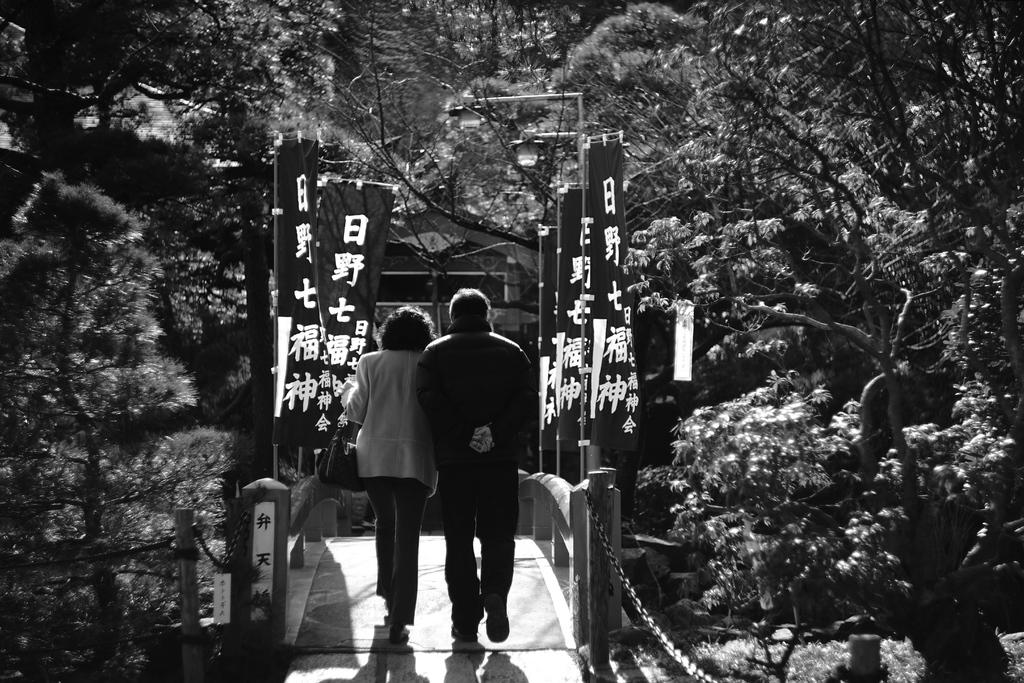What are the two persons in the image doing? The two persons in the image are walking. What object can be seen in the image that is made of metal? There is an iron chain in the image. What type of symbolic objects are present in the image? There are flags in the image. What type of natural vegetation is visible in the image? There are many trees around in the image. What type of letter is being delivered by the crook in the image? There is no crook or letter present in the image. What type of ear is visible on the person walking in the image? There is no ear visible on the person walking in the image, as the image does not show a close-up of their face. 